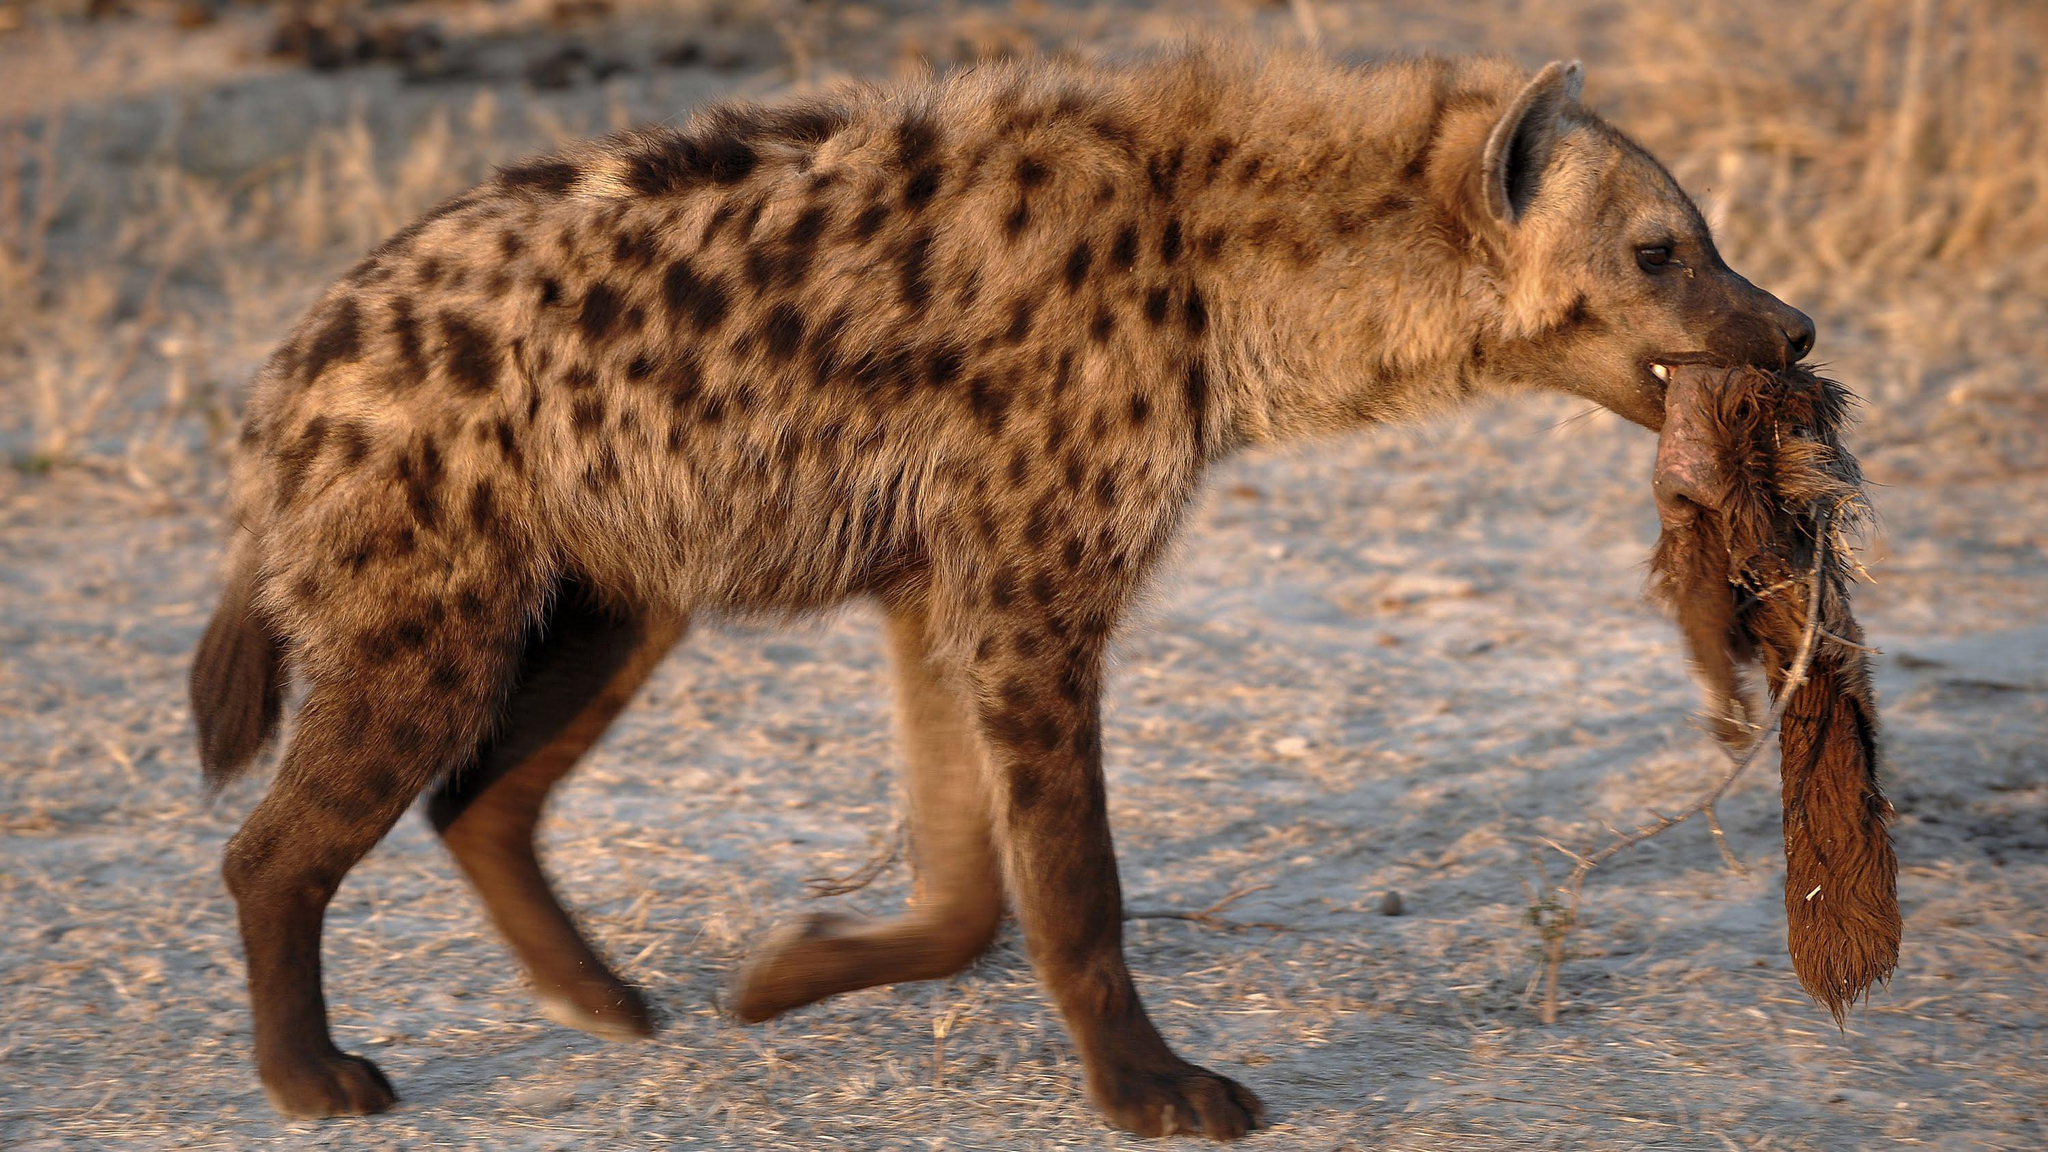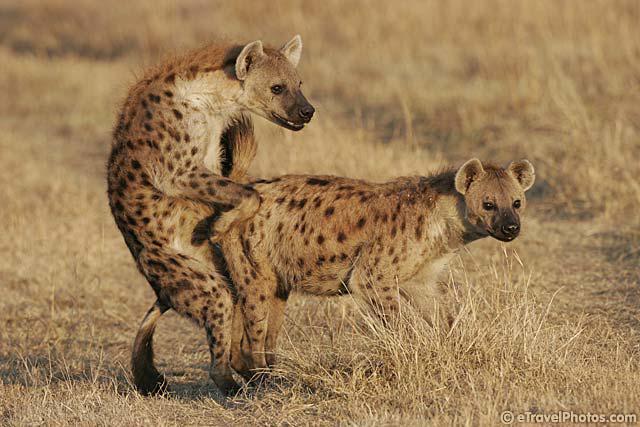The first image is the image on the left, the second image is the image on the right. For the images displayed, is the sentence "An image shows a hyena carrying prey in its jaws." factually correct? Answer yes or no. Yes. 